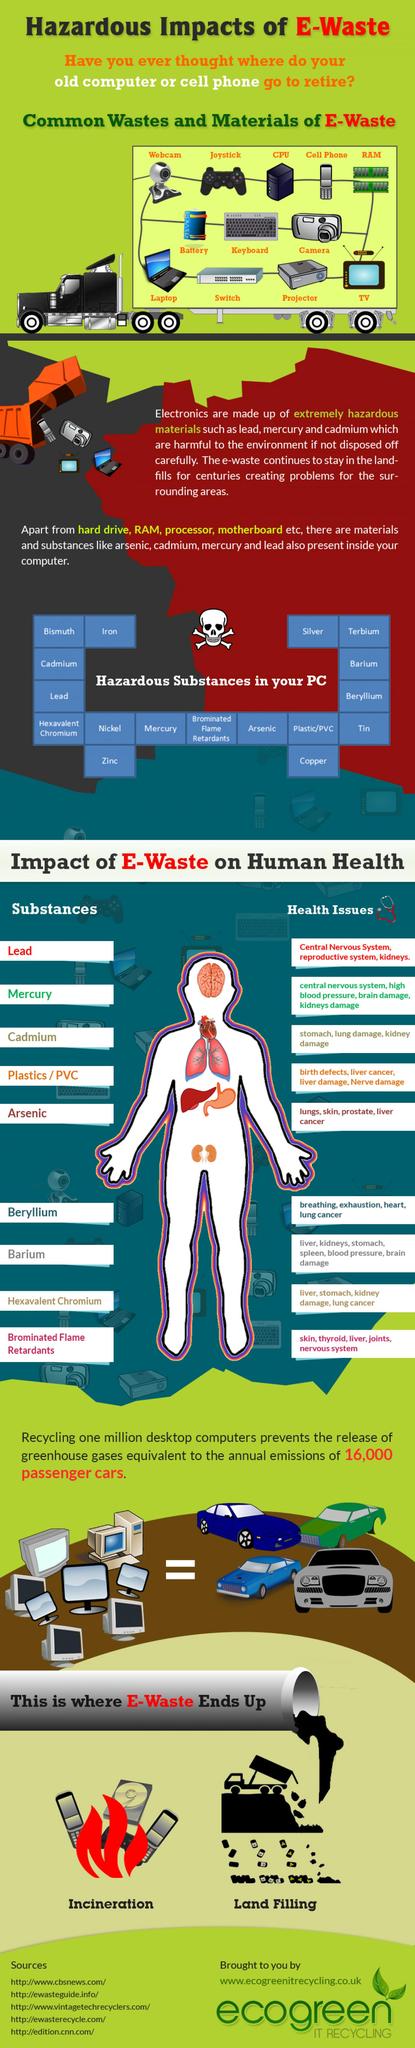Point out several critical features in this image. Seventeen dangerous substances have been identified in PCs, as shown in the chart. Of the substances listed in the chart, five have the potential to affect the kidney. The substances found within PCs that can cause stomach damage include cadmium, barium, and hexavalent chromium. The chart lists 12 common materials found in e-waste. The substances found inside PC that have been linked to lung cancer include beryllium and hexavalent chromium. 